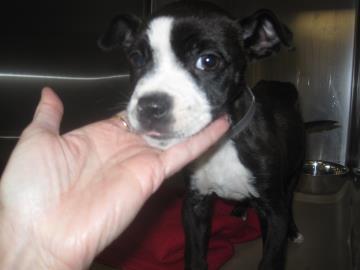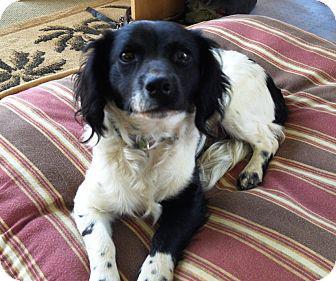The first image is the image on the left, the second image is the image on the right. Examine the images to the left and right. Is the description "The left image contains a human hand touching a black and white dog." accurate? Answer yes or no. Yes. The first image is the image on the left, the second image is the image on the right. Analyze the images presented: Is the assertion "A human is touching the dog in the image on the left." valid? Answer yes or no. Yes. 